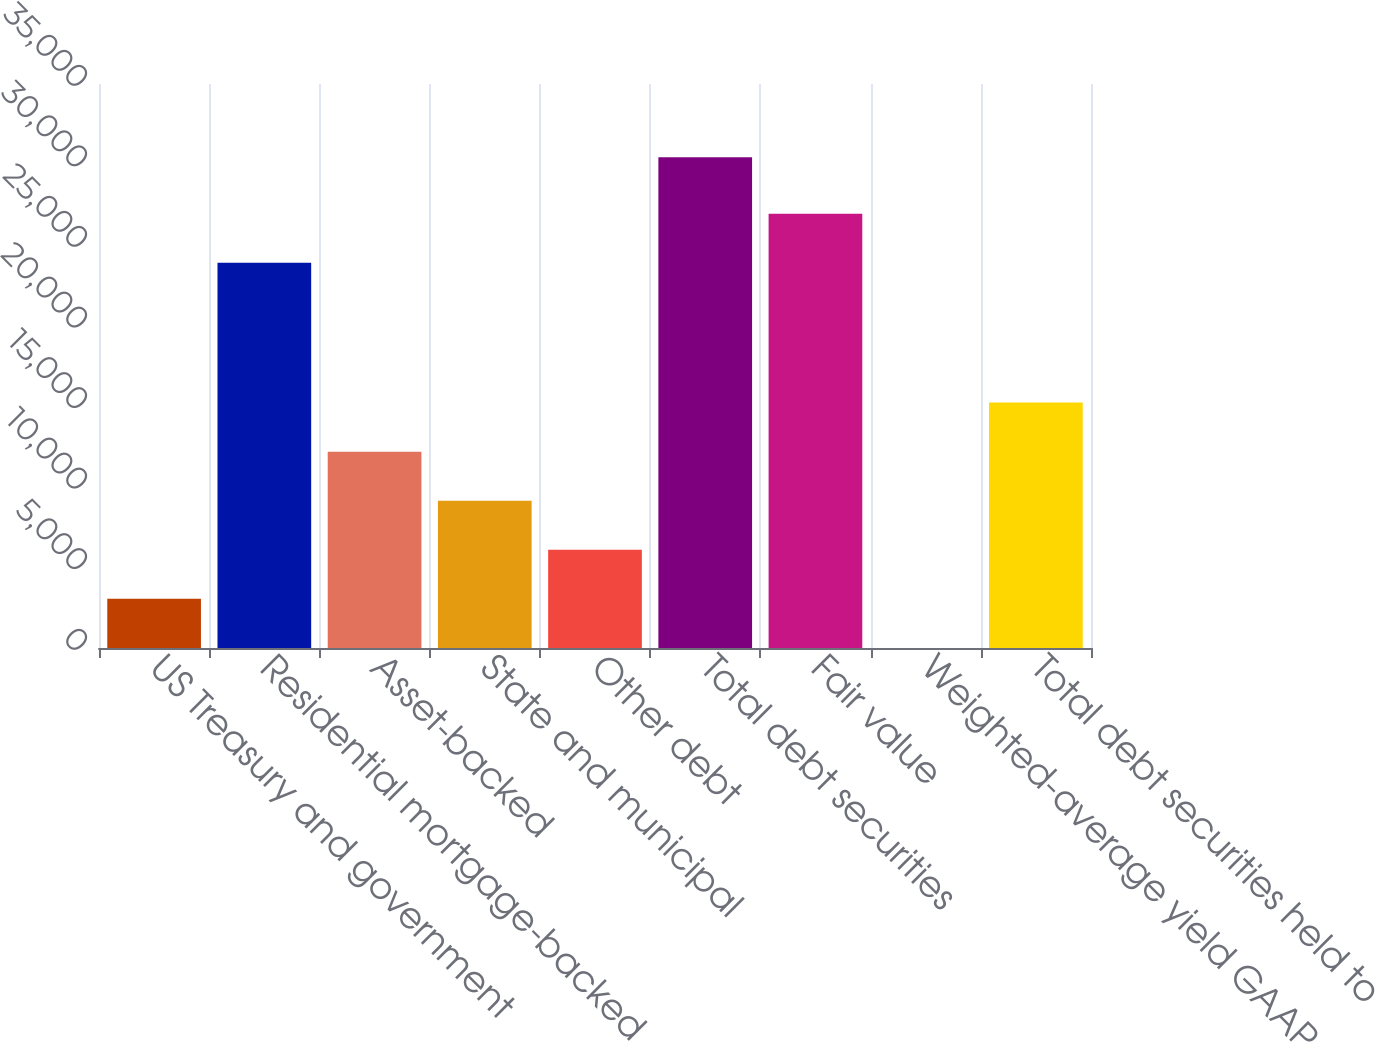Convert chart. <chart><loc_0><loc_0><loc_500><loc_500><bar_chart><fcel>US Treasury and government<fcel>Residential mortgage-backed<fcel>Asset-backed<fcel>State and municipal<fcel>Other debt<fcel>Total debt securities<fcel>Fair value<fcel>Weighted-average yield GAAP<fcel>Total debt securities held to<nl><fcel>3050.28<fcel>23904<fcel>12184.5<fcel>9139.78<fcel>6095.03<fcel>30453<fcel>26948.8<fcel>5.53<fcel>15229.3<nl></chart> 